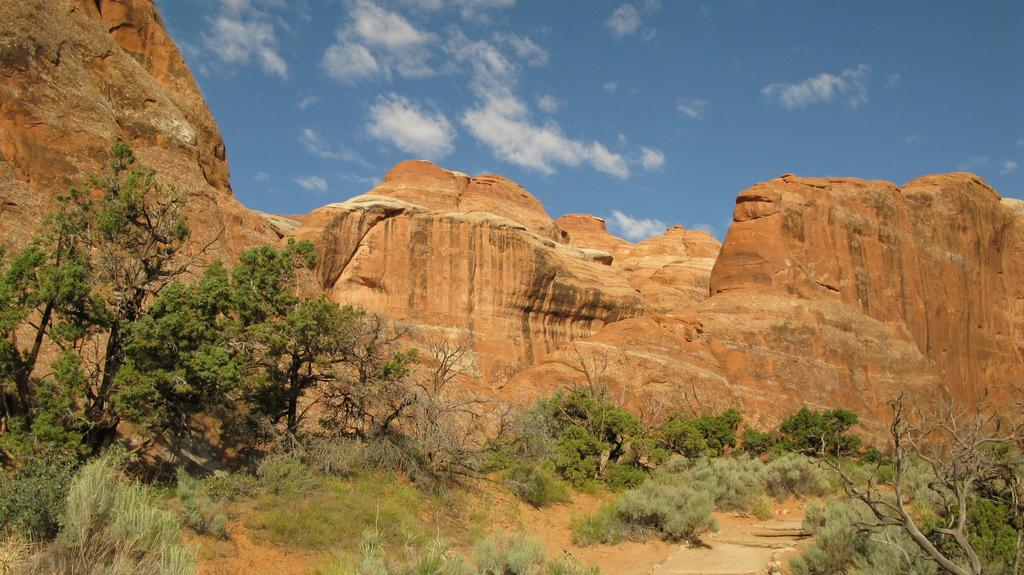What type of vegetation is present in the image? There are many trees in the image. What is the other prominent feature in the image? There is a rock in the image. What is the color of the rock? The rock is brown in color. What can be seen in the sky in the image? There are clouds visible in the image. What is the color of the sky in the image? The sky is blue in the image. What grade does the rock receive for its health in the image? The image does not provide any information about the rock's health or grade, as it is a static object in the image. 